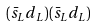Convert formula to latex. <formula><loc_0><loc_0><loc_500><loc_500>( \bar { s } _ { L } d _ { L } ) ( \bar { s } _ { L } d _ { L } )</formula> 